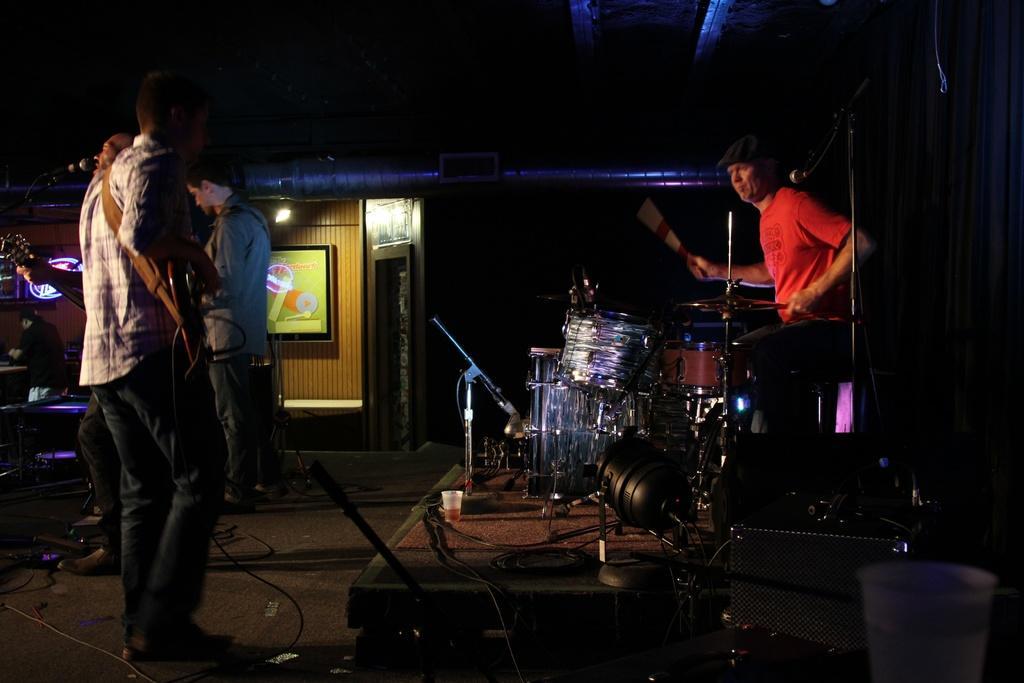How would you summarize this image in a sentence or two? A person is standing and playing guitar. A person wearing red t shirt is playing drums. Another person is standing in the background. There is a cup on the stage. In the background there are some lights and a wall. And on the wall there is a television. 